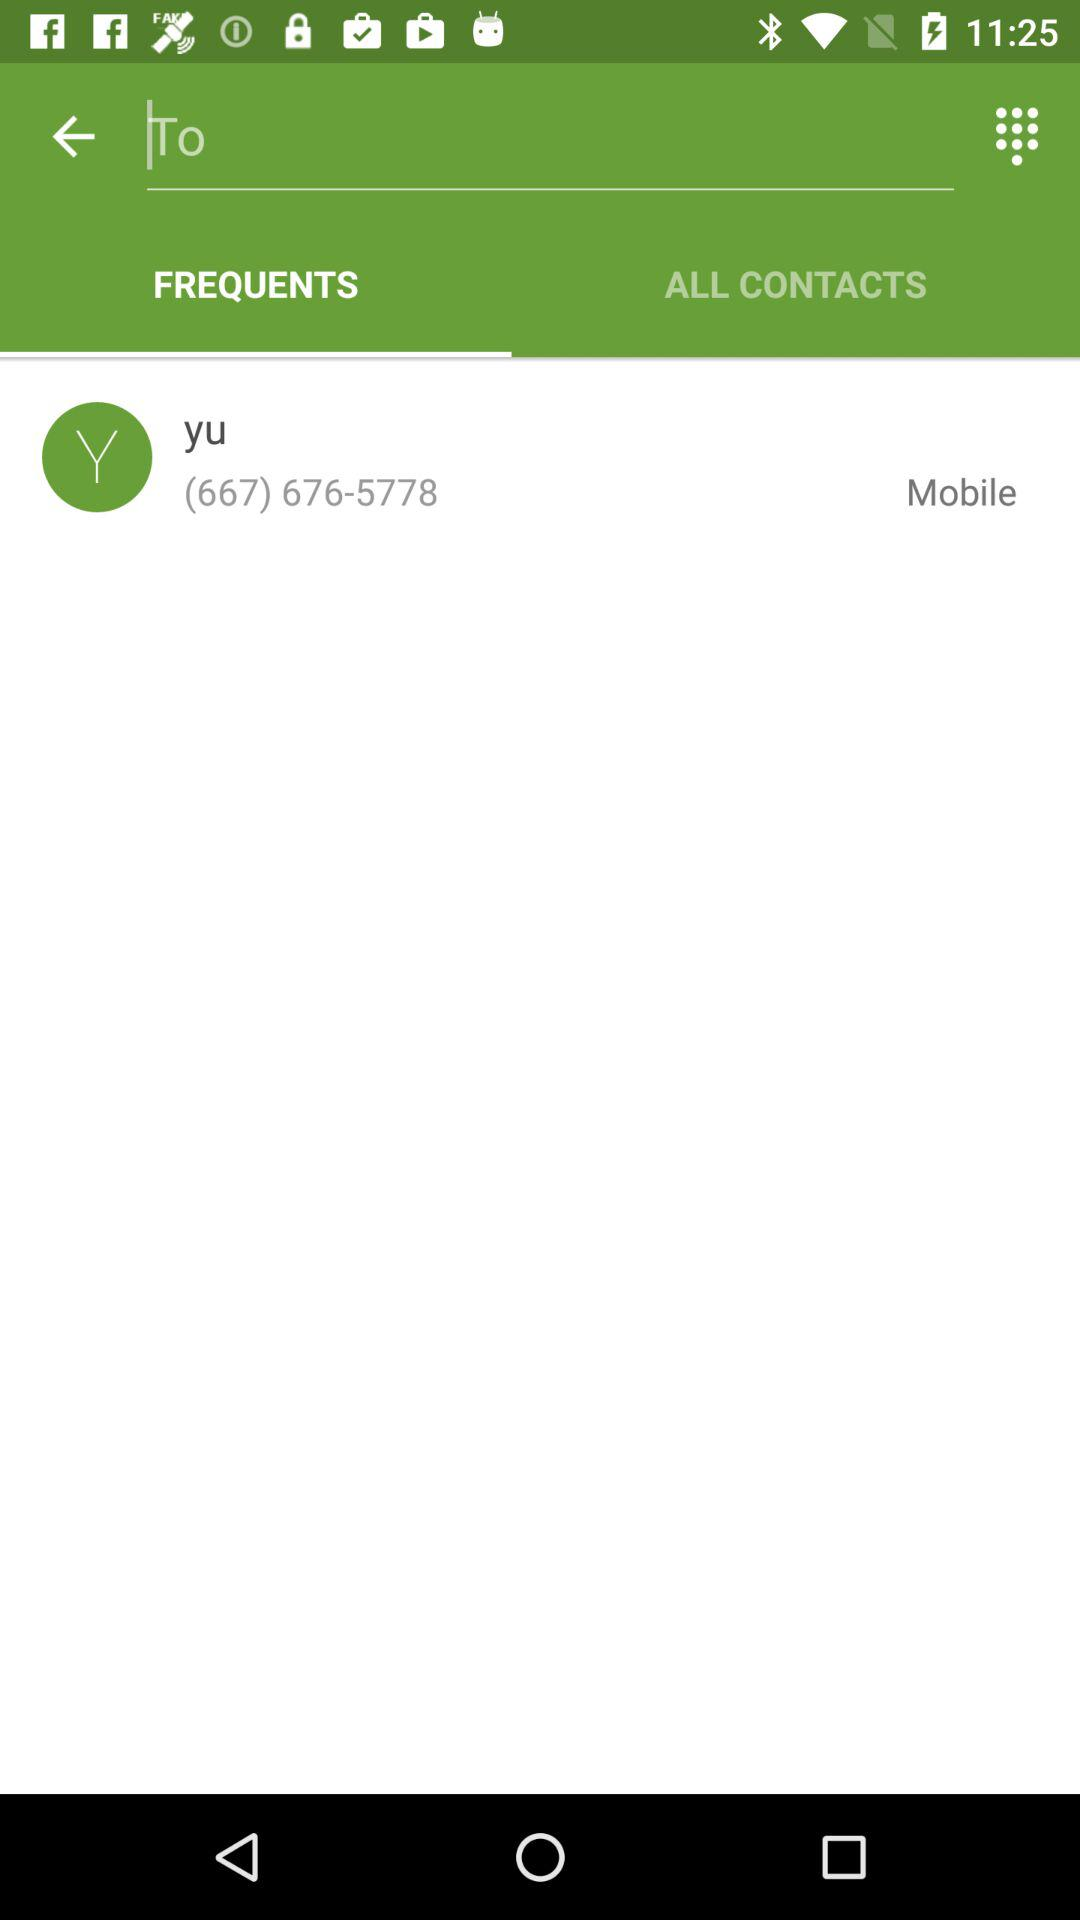What is the phone number? The phone number is (667) 676-5778. 